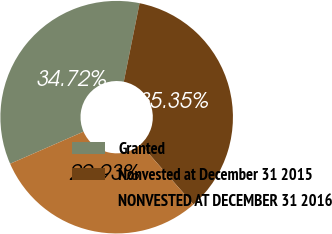Convert chart to OTSL. <chart><loc_0><loc_0><loc_500><loc_500><pie_chart><fcel>Granted<fcel>Nonvested at December 31 2015<fcel>NONVESTED AT DECEMBER 31 2016<nl><fcel>34.72%<fcel>35.35%<fcel>29.93%<nl></chart> 